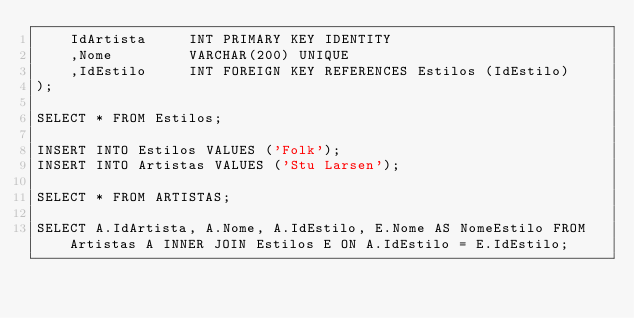Convert code to text. <code><loc_0><loc_0><loc_500><loc_500><_SQL_>    IdArtista     INT PRIMARY KEY IDENTITY
    ,Nome		  VARCHAR(200) UNIQUE
    ,IdEstilo     INT FOREIGN KEY REFERENCES Estilos (IdEstilo)
);

SELECT * FROM Estilos;

INSERT INTO Estilos VALUES ('Folk');
INSERT INTO Artistas VALUES ('Stu Larsen');

SELECT * FROM ARTISTAS;

SELECT A.IdArtista, A.Nome, A.IdEstilo, E.Nome AS NomeEstilo FROM Artistas A INNER JOIN Estilos E ON A.IdEstilo = E.IdEstilo;</code> 